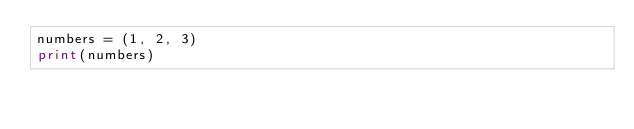Convert code to text. <code><loc_0><loc_0><loc_500><loc_500><_Python_>numbers = (1, 2, 3)
print(numbers)
</code> 